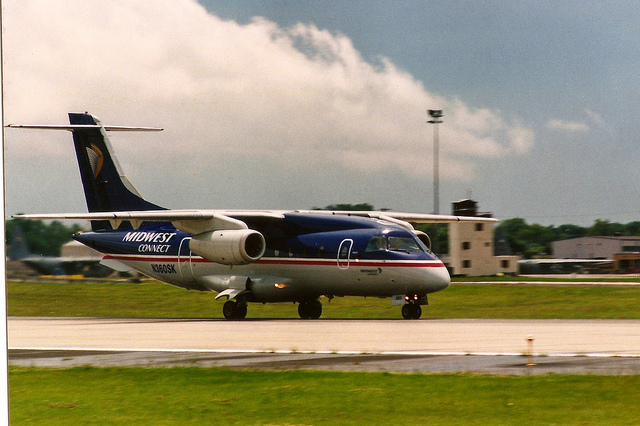Please transcribe the text in this image. MIDWEST CONNECT 360SK 